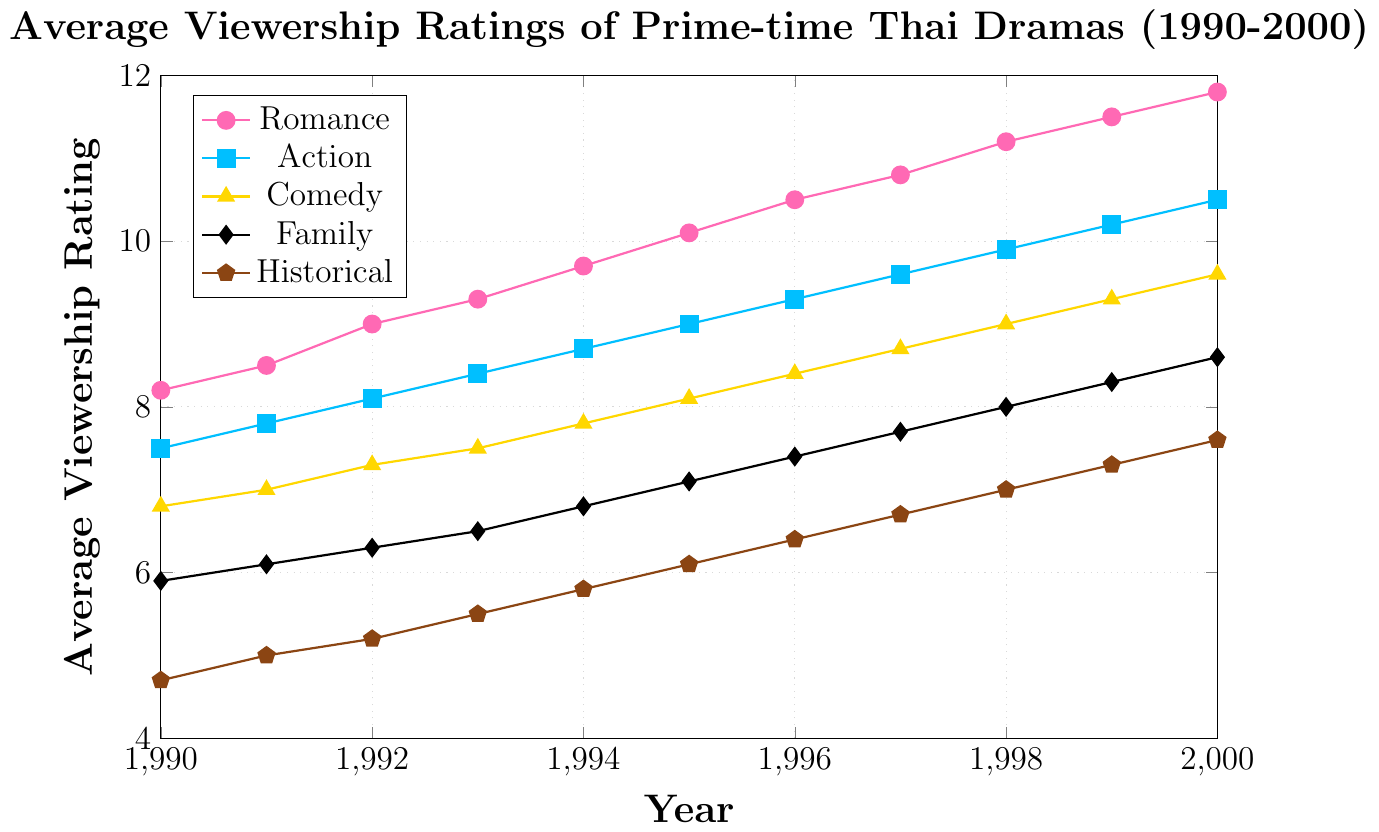What was the highest average viewership rating for the Romance genre? Locate the Romance genre's line and identify the highest point on the y-axis. In the year 2000, the rating is 11.8.
Answer: 11.8 Which genre had the lowest viewership rating in 1990? Check the viewership ratings for all genres in 1990 and identify the lowest value. Historical has the lowest rating at 4.7.
Answer: Historical In which year did the Comedy genre first reach an average rating of 9.0? Trace the Comedy genre's line and find the year where it first crosses the 9.0 mark on the y-axis. This occurs in 1998.
Answer: 1998 What was the difference in viewership ratings between Action and Family dramas in 1995? Locate the data points for both Action and Family in 1995. Action has 9.0, Family has 7.1. The difference is 9.0 - 7.1 = 1.9.
Answer: 1.9 Which genre shows the most consistent increase in ratings from 1990 to 2000? Compare the slopes of all lines. Romance has a steady upward slope from 8.2 in 1990 to 11.8 in 2000.
Answer: Romance Between 1997 and 1998, which genre experienced the greatest increase in viewership rating? Calculate the difference for each genre between 1997 and 1998. Romance increased from 10.8 to 11.2 (+0.4), Action from 9.6 to 9.9 (+0.3), Comedy from 8.7 to 9.0 (+0.3), Family from 7.7 to 8.0 (+0.3), Historical from 6.7 to 7.0 (+0.3). Romance had the greatest increase.
Answer: Romance Was the viewership rating of Family dramas ever higher than Comedy dramas during this period? Compare the Family and Comedy lines across all years. The Family rating is consistently below Comedy in each year.
Answer: No What was the average viewership rating of Historical dramas from 1990 to 2000? Sum the ratings from each year and divide by the number of years: (4.7 + 5.0 + 5.2 + 5.5 + 5.8 + 6.1 + 6.4 + 6.7 + 7.0 + 7.3 + 7.6) / 11 = 6.16.
Answer: 6.16 By how much did the viewership rating for Family dramas increase from 1990 to 2000? Subtract the 1990 rating from the 2000 rating for Family dramas: 8.6 - 5.9 = 2.7.
Answer: 2.7 